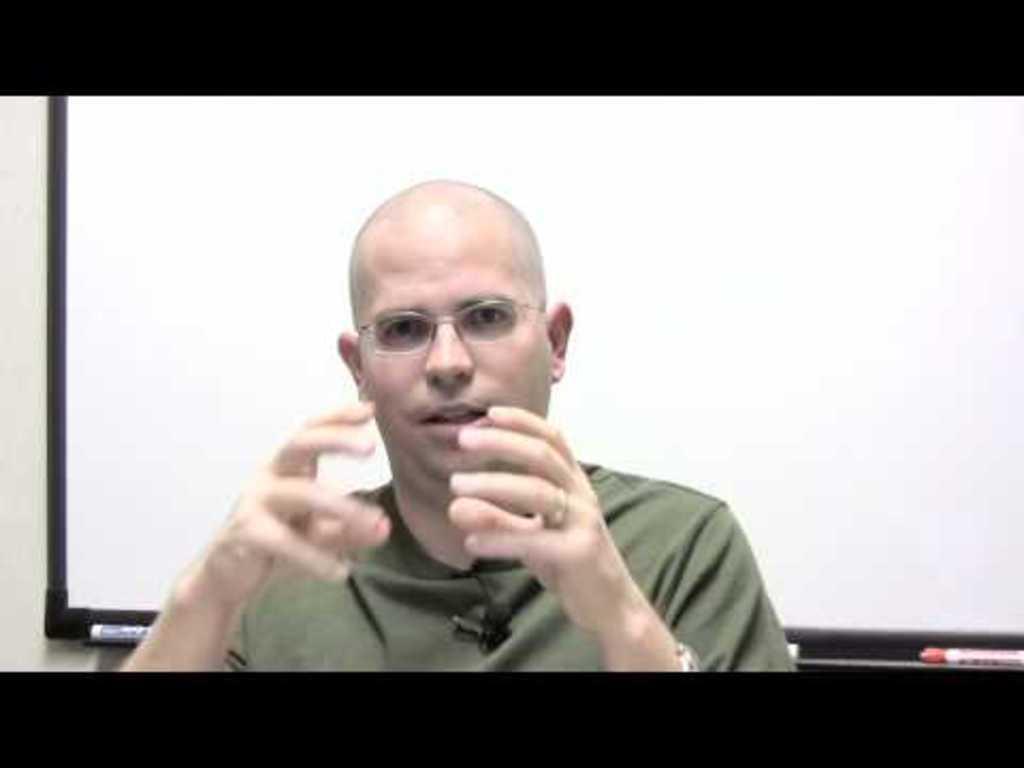Describe this image in one or two sentences. In this image I see a man who is wearing t-shirt and I see that he is wearing spectacle. In the background I see the white board and I see the markers and it is black over here and here. 